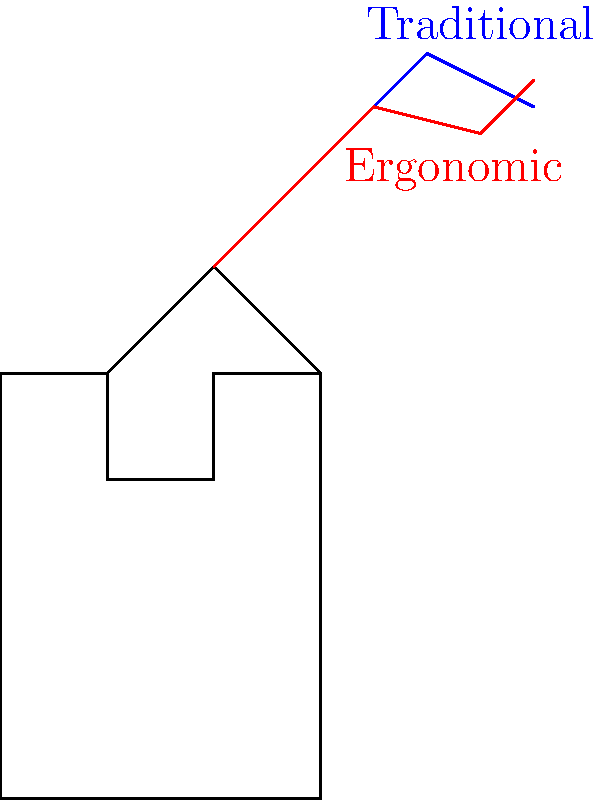As an olive oil producer, you're considering updating your harvesting tools. The illustration shows a worker using two different olive picking tool designs: a traditional straight tool (blue) and an ergonomic curved tool (red). Which design is likely to reduce the risk of musculoskeletal disorders (MSDs) in workers during prolonged use, and why? To answer this question, we need to consider the ergonomic principles and their impact on musculoskeletal health:

1. Neutral posture: The ergonomic tool (red) allows for a more neutral wrist position compared to the traditional tool (blue).

2. Force reduction: The curved design of the ergonomic tool helps distribute the force more evenly across the hand and wrist.

3. Reduced repetitive motion: The ergonomic design minimizes the need for extreme wrist movements during picking.

4. Grip comfort: The curved handle of the ergonomic tool provides a more natural grip, reducing hand fatigue.

5. Reach reduction: The ergonomic tool's shape may allow workers to reach olives with less stretching, reducing shoulder strain.

6. Energy efficiency: The improved design of the ergonomic tool likely requires less energy to use over extended periods.

7. Biomechanical advantage: The curved shape provides a mechanical advantage, potentially reducing the force required for picking.

Given these factors, the ergonomic curved tool (red) is more likely to reduce the risk of MSDs in workers during prolonged use. It promotes better posture, reduces strain on joints and muscles, and improves overall efficiency in the olive picking process.
Answer: Ergonomic curved tool (red) 